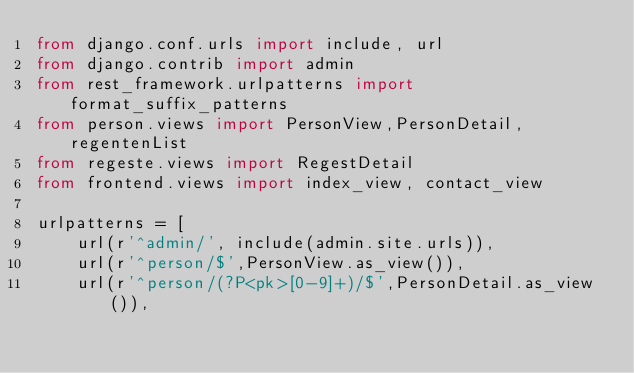Convert code to text. <code><loc_0><loc_0><loc_500><loc_500><_Python_>from django.conf.urls import include, url
from django.contrib import admin
from rest_framework.urlpatterns import format_suffix_patterns
from person.views import PersonView,PersonDetail,regentenList
from regeste.views import RegestDetail
from frontend.views import index_view, contact_view

urlpatterns = [
    url(r'^admin/', include(admin.site.urls)),
    url(r'^person/$',PersonView.as_view()),
    url(r'^person/(?P<pk>[0-9]+)/$',PersonDetail.as_view()),</code> 